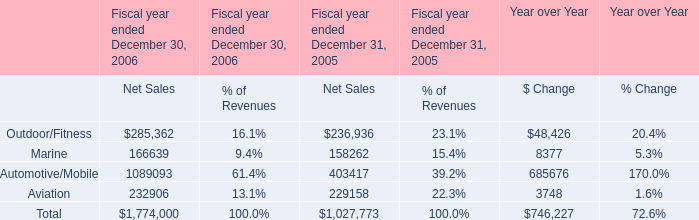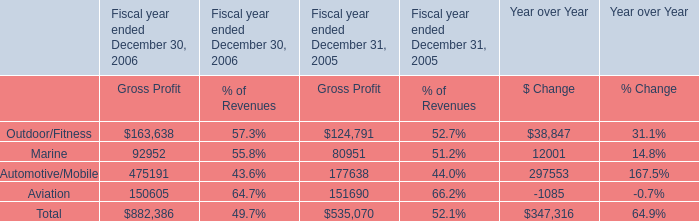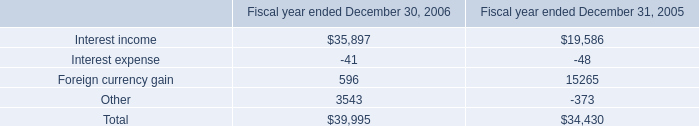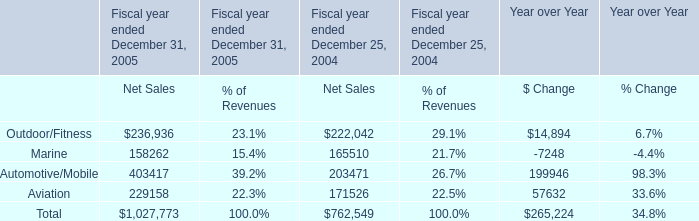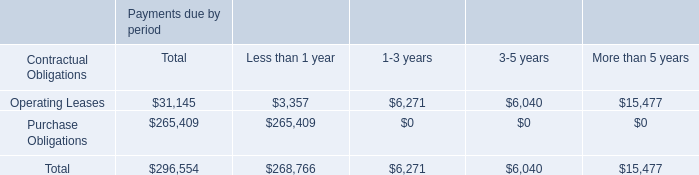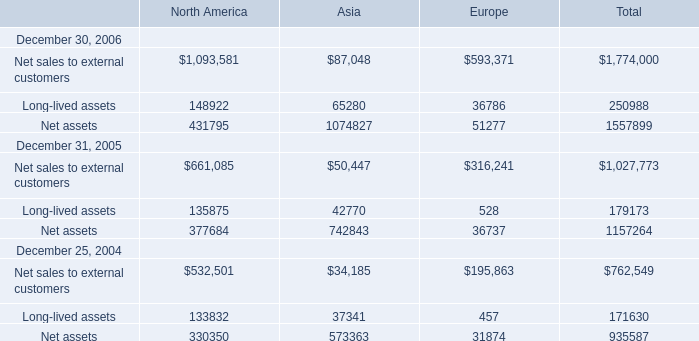What is the growing rate of Long-lived assets of Asia in Table 5 in the years with the least Other in Table 2? 
Computations: ((42770 - 37341) / 37341)
Answer: 0.14539. 